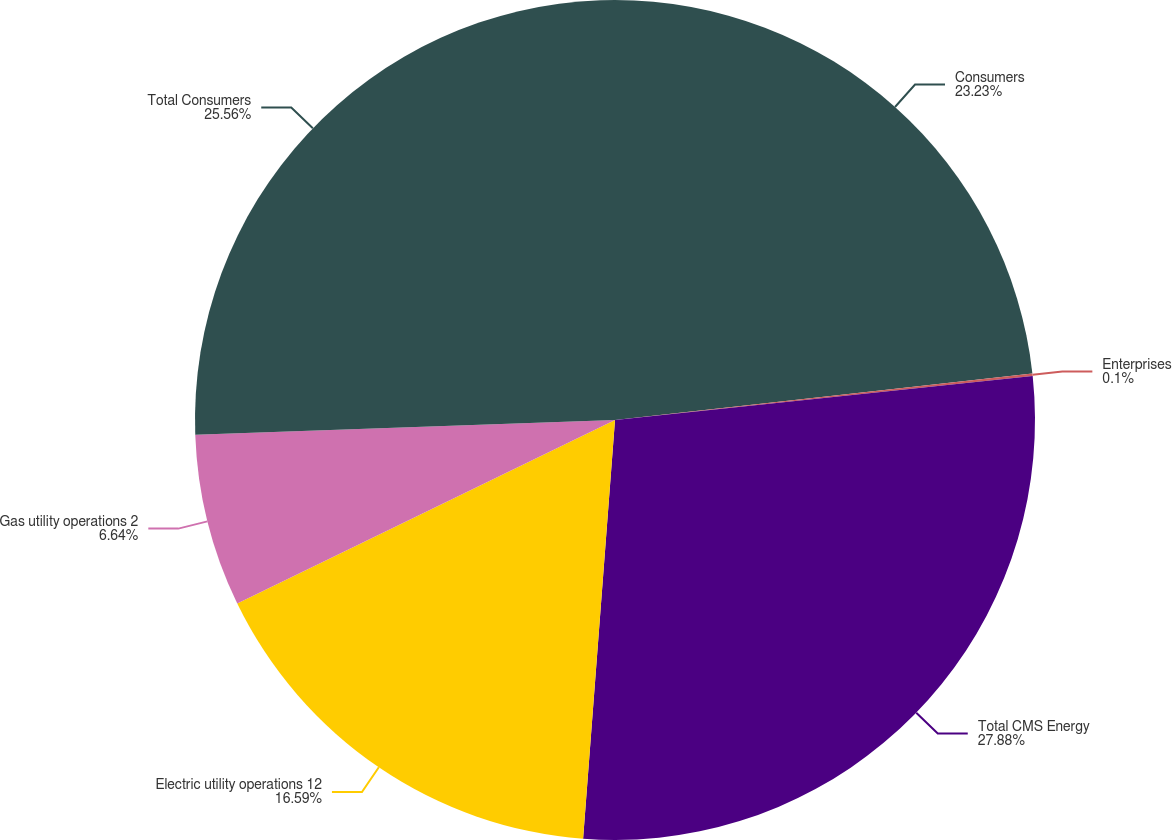Convert chart. <chart><loc_0><loc_0><loc_500><loc_500><pie_chart><fcel>Consumers<fcel>Enterprises<fcel>Total CMS Energy<fcel>Electric utility operations 12<fcel>Gas utility operations 2<fcel>Total Consumers<nl><fcel>23.23%<fcel>0.1%<fcel>27.88%<fcel>16.59%<fcel>6.64%<fcel>25.56%<nl></chart> 